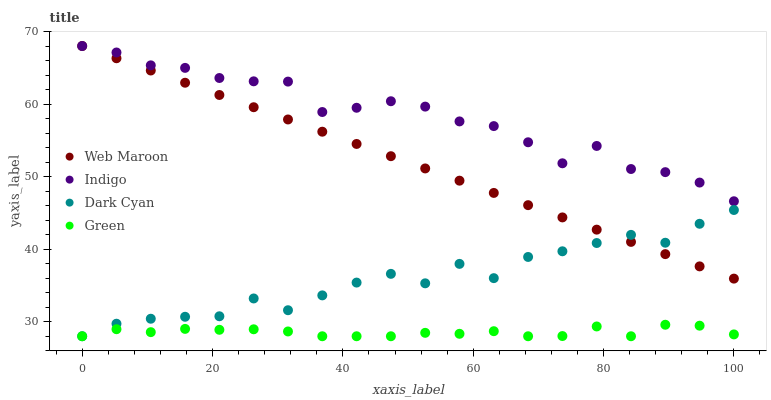Does Green have the minimum area under the curve?
Answer yes or no. Yes. Does Indigo have the maximum area under the curve?
Answer yes or no. Yes. Does Indigo have the minimum area under the curve?
Answer yes or no. No. Does Green have the maximum area under the curve?
Answer yes or no. No. Is Web Maroon the smoothest?
Answer yes or no. Yes. Is Dark Cyan the roughest?
Answer yes or no. Yes. Is Indigo the smoothest?
Answer yes or no. No. Is Indigo the roughest?
Answer yes or no. No. Does Dark Cyan have the lowest value?
Answer yes or no. Yes. Does Indigo have the lowest value?
Answer yes or no. No. Does Web Maroon have the highest value?
Answer yes or no. Yes. Does Green have the highest value?
Answer yes or no. No. Is Green less than Indigo?
Answer yes or no. Yes. Is Indigo greater than Green?
Answer yes or no. Yes. Does Web Maroon intersect Dark Cyan?
Answer yes or no. Yes. Is Web Maroon less than Dark Cyan?
Answer yes or no. No. Is Web Maroon greater than Dark Cyan?
Answer yes or no. No. Does Green intersect Indigo?
Answer yes or no. No. 